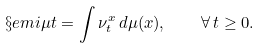<formula> <loc_0><loc_0><loc_500><loc_500>\S e m i { \mu } { t } = \int \nu _ { t } ^ { x } \, d \mu ( x ) , \quad \forall \, t \geq 0 .</formula> 